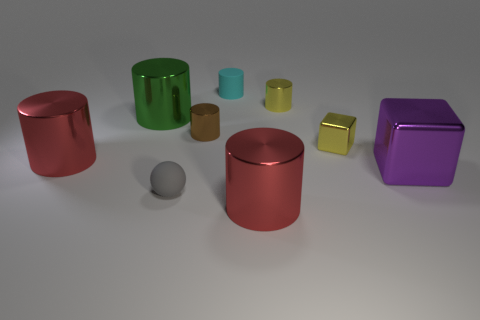What size is the purple cube that is the same material as the tiny yellow cylinder? The purple cube, which shares the shiny, metallic material characteristic with the tiny yellow cylinder, is large in size compared to the various other objects present. 